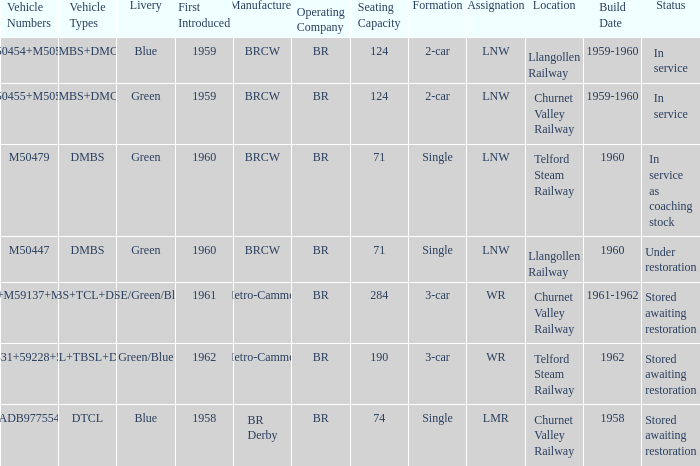What status is the vehicle numbers of adb977554? Stored awaiting restoration. 